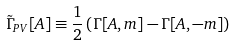Convert formula to latex. <formula><loc_0><loc_0><loc_500><loc_500>\tilde { \Gamma } _ { P V } [ A ] \equiv \frac { 1 } { 2 } \left ( \Gamma [ A , m ] - \Gamma [ A , - m ] \right )</formula> 